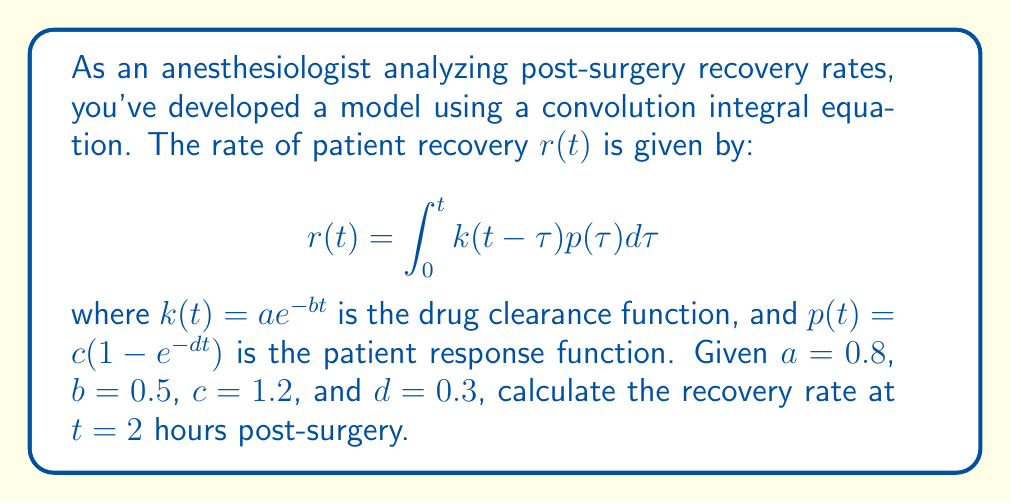Could you help me with this problem? To solve this problem, we'll follow these steps:

1) First, we need to substitute the given functions into the convolution integral:

   $$r(2) = \int_0^2 k(2-\tau)p(\tau)d\tau = \int_0^2 ae^{-b(2-\tau)} \cdot c(1-e^{-d\tau})d\tau$$

2) Substitute the given values:

   $$r(2) = \int_0^2 0.8e^{-0.5(2-\tau)} \cdot 1.2(1-e^{-0.3\tau})d\tau$$

3) Simplify the integrand:

   $$r(2) = 0.96 \int_0^2 e^{-1+0.5\tau} - e^{-1+0.5\tau-0.3\tau}d\tau$$
   $$r(2) = 0.96 \int_0^2 e^{-1+0.5\tau} - e^{-1+0.2\tau}d\tau$$

4) Integrate:

   $$r(2) = 0.96 \left[\frac{2}{0.5}e^{-1+0.5\tau} - \frac{5}{0.2}e^{-1+0.2\tau}\right]_0^2$$

5) Evaluate the integral:

   $$r(2) = 0.96 \left[(4e^{0} - 25e^{-0.6}) - (4e^{-1} - 25e^{-1})\right]$$

6) Simplify:

   $$r(2) = 0.96 \left[4 - 25e^{-0.6} - 4e^{-1} + 25e^{-1}\right]$$
   $$r(2) = 0.96 \left[4 - 25e^{-0.6} + 21e^{-1}\right]$$

7) Calculate the final value:

   $$r(2) \approx 0.96 \cdot 2.7128 \approx 2.6043$$
Answer: $2.6043$ 